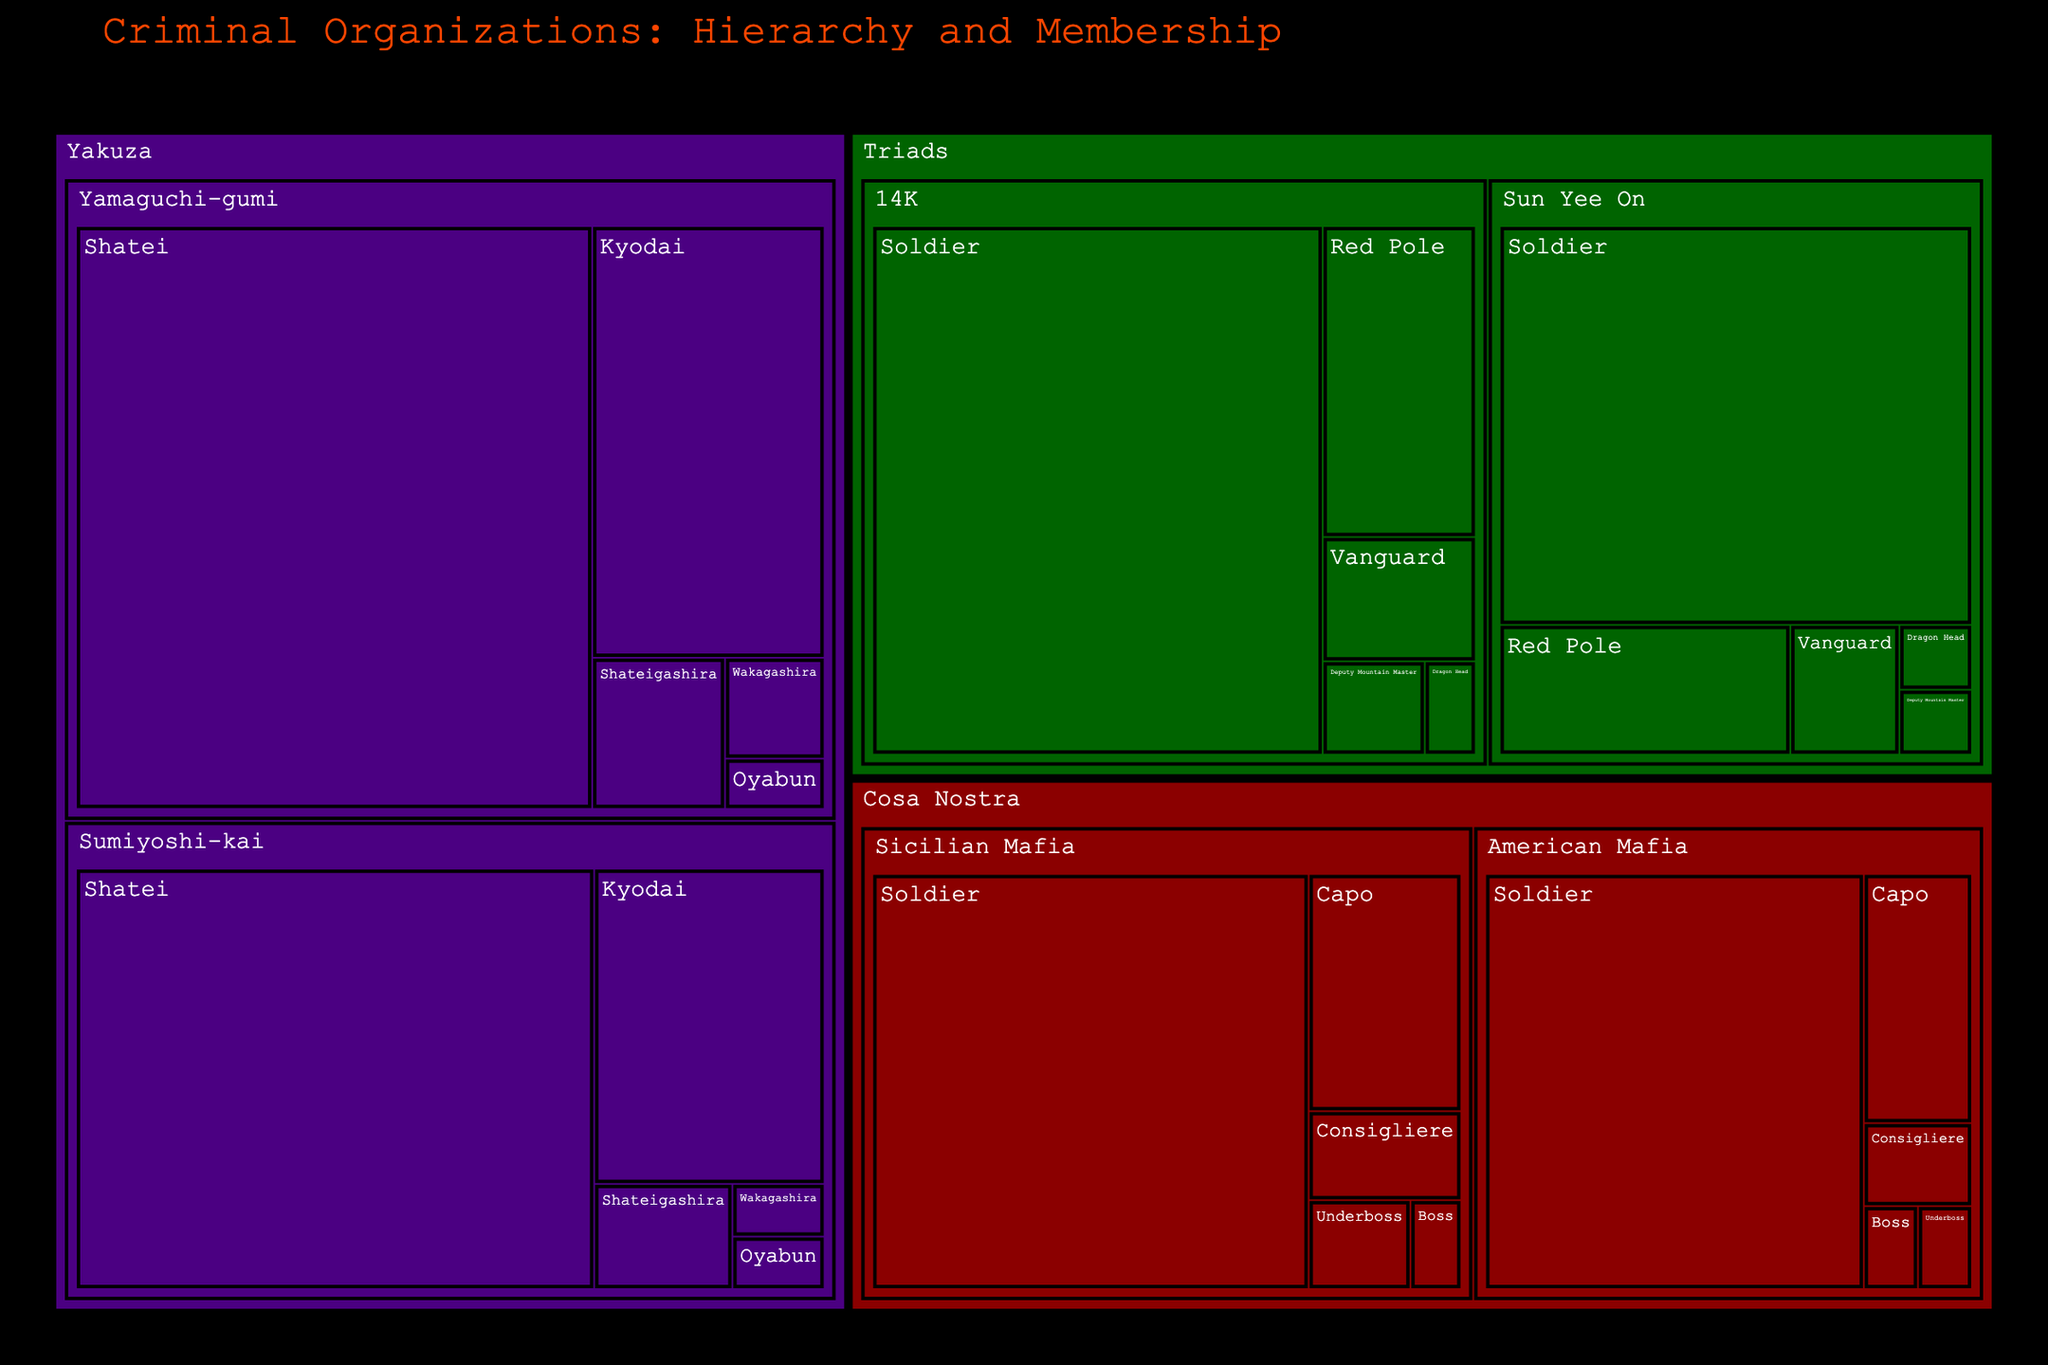What's the title of the figure? The title is displayed at the top of the figure. Reading it gives an immediate understanding of the overall context.
Answer: Criminal Organizations: Hierarchy and Membership Which organization has the highest number of members? By visually analyzing the largest section, which implies the highest value, you can determine the organization with the most extensive membership.
Answer: Yakuza How many members are in the Triads' 14K division? Locate the Triads organization, then within it, find the 14K division to sum up its roles' member counts (1+2+4+10+50).
Answer: 67 Which role in the American Mafia has the fewest members? Within the Cosa Nostra's American Mafia division, identify the smallest labeled section by member count.
Answer: Boss and Underboss (Both have 1) Compare the total members of the Yamaguchi-gumi with the Sumiyoshi-kai. Which division has more members, and by how many? Sum the members of Yamaguchi-gumi (1+2+4+20+60) and Sumiyoshi-kai (1+1+3+15+45), then compare and subtract the smaller total from the larger one. Yamaguchi-gumi has 87 members (1+2+4+20+60), Sumiyoshi-kai has 65 members (1+1+3+15+45). The difference is 87-65.
Answer: Yamaguchi-gumi, by 22 members What's the total number of members in the Cosa Nostra's Sicilian Mafia division? Summing the member counts for all roles within this division: (1+2+3+8+40).
Answer: 54 Which color represents the Triads organization? Identify the color used for the sections labeled with the Triads' name, which reflects the specific color associated with this organization in the figure.
Answer: Dark Green Compare the number of members in the Capo role between the Sicilian Mafia and American Mafia. Which has more members? Find the Capo role in both the Sicilian Mafia (8 members) and the American Mafia (6 members), and compare these values.
Answer: Sicilian Mafia, 8 vs. 6 What is the combined total number of members in the role of Soldiers across all organizations? Identify the Soldiers' role in each division and sum their member counts: (40+35+60+45+50+40).
Answer: 270 Identify the division with the second-highest number of members among all criminal organizations. Sum the member counts for each division and rank them to find the second-highest total. First, sum members: Yamaguchi-gumi (87), Sicilian Mafia (54), American Mafia (45), Sumiyoshi-kai (65), 14K (67), and Sun Yee On (53). The second-highest is the 14K division with 67 members.
Answer: 14K with 67 members 